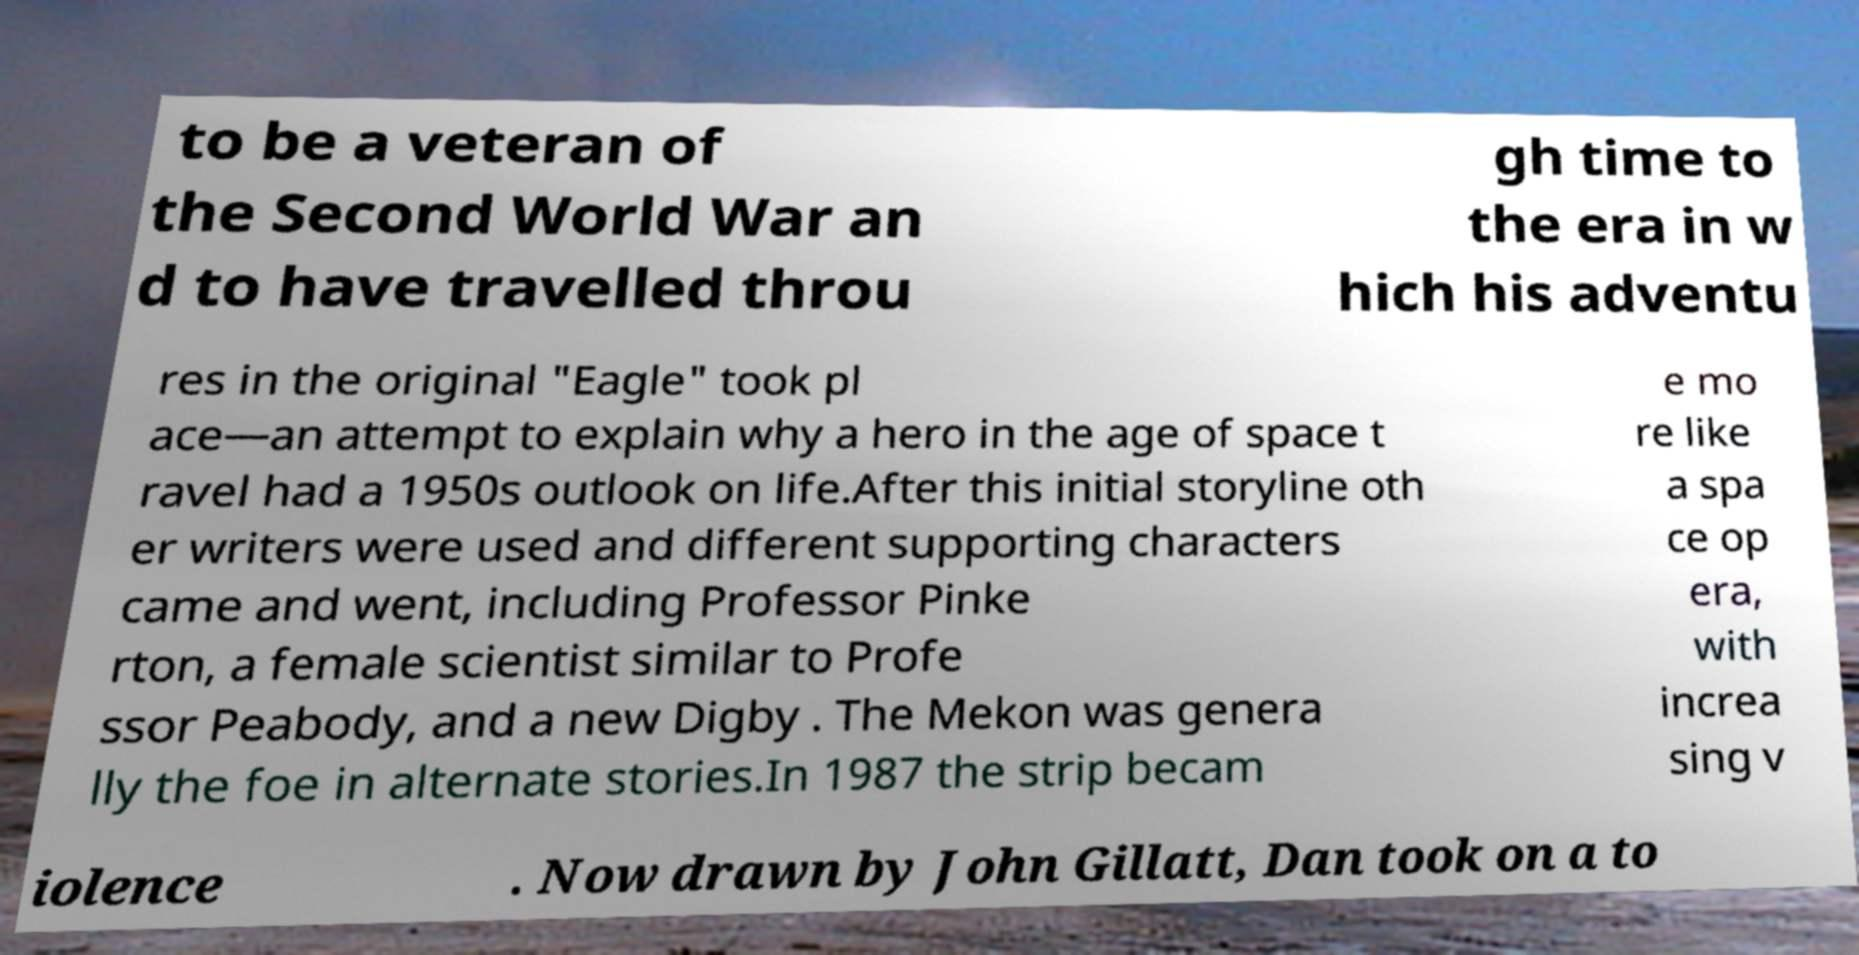Can you read and provide the text displayed in the image?This photo seems to have some interesting text. Can you extract and type it out for me? to be a veteran of the Second World War an d to have travelled throu gh time to the era in w hich his adventu res in the original "Eagle" took pl ace—an attempt to explain why a hero in the age of space t ravel had a 1950s outlook on life.After this initial storyline oth er writers were used and different supporting characters came and went, including Professor Pinke rton, a female scientist similar to Profe ssor Peabody, and a new Digby . The Mekon was genera lly the foe in alternate stories.In 1987 the strip becam e mo re like a spa ce op era, with increa sing v iolence . Now drawn by John Gillatt, Dan took on a to 